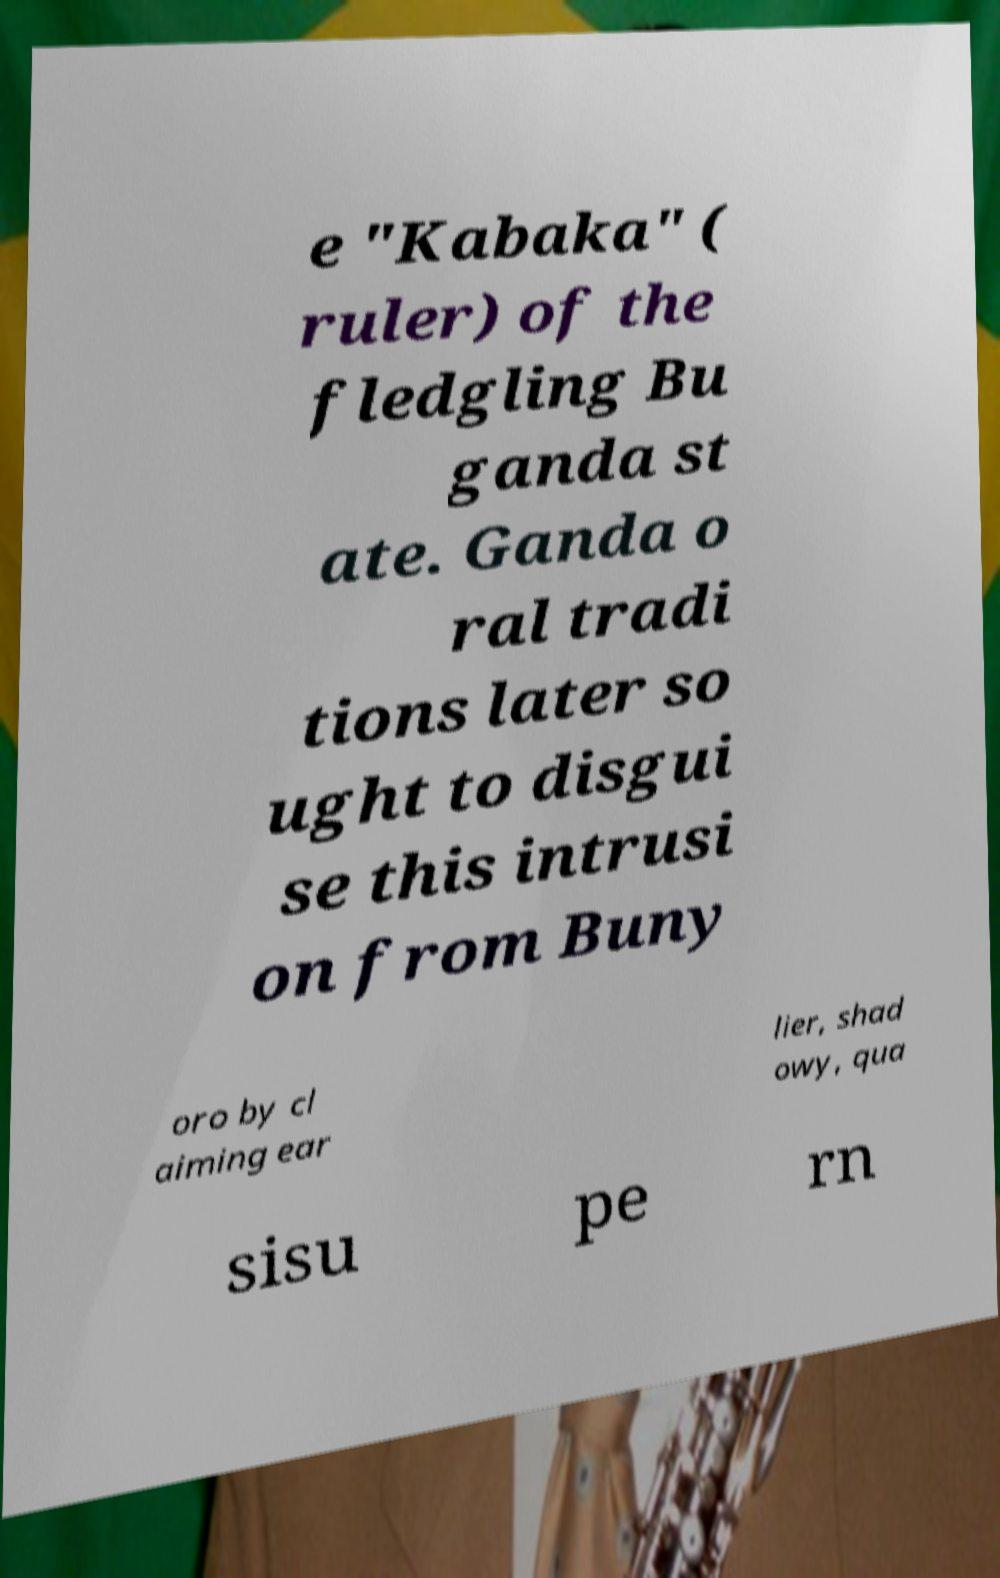Could you extract and type out the text from this image? e "Kabaka" ( ruler) of the fledgling Bu ganda st ate. Ganda o ral tradi tions later so ught to disgui se this intrusi on from Buny oro by cl aiming ear lier, shad owy, qua sisu pe rn 